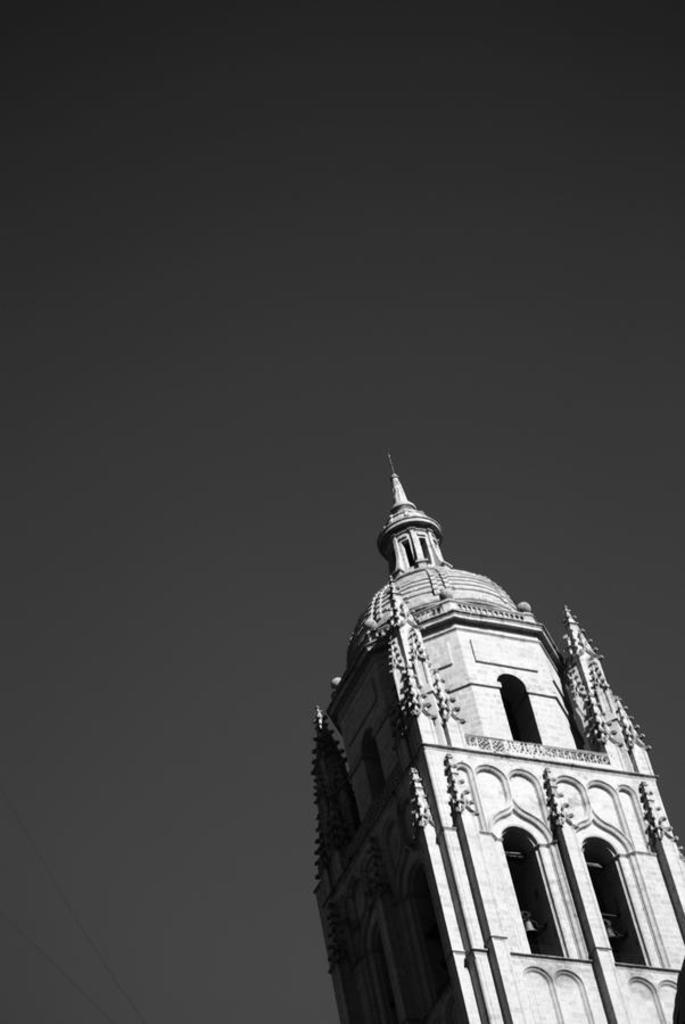What type of view is shown in the image? The image is an outside view. What structure can be seen on the right side of the image? There is a tower on the right side of the image. What is visible at the top of the image? The sky is visible at the top of the image. What type of range can be seen in the image? There is no range present in the image. Is there any wire visible in the image? There is no wire visible in the image. 